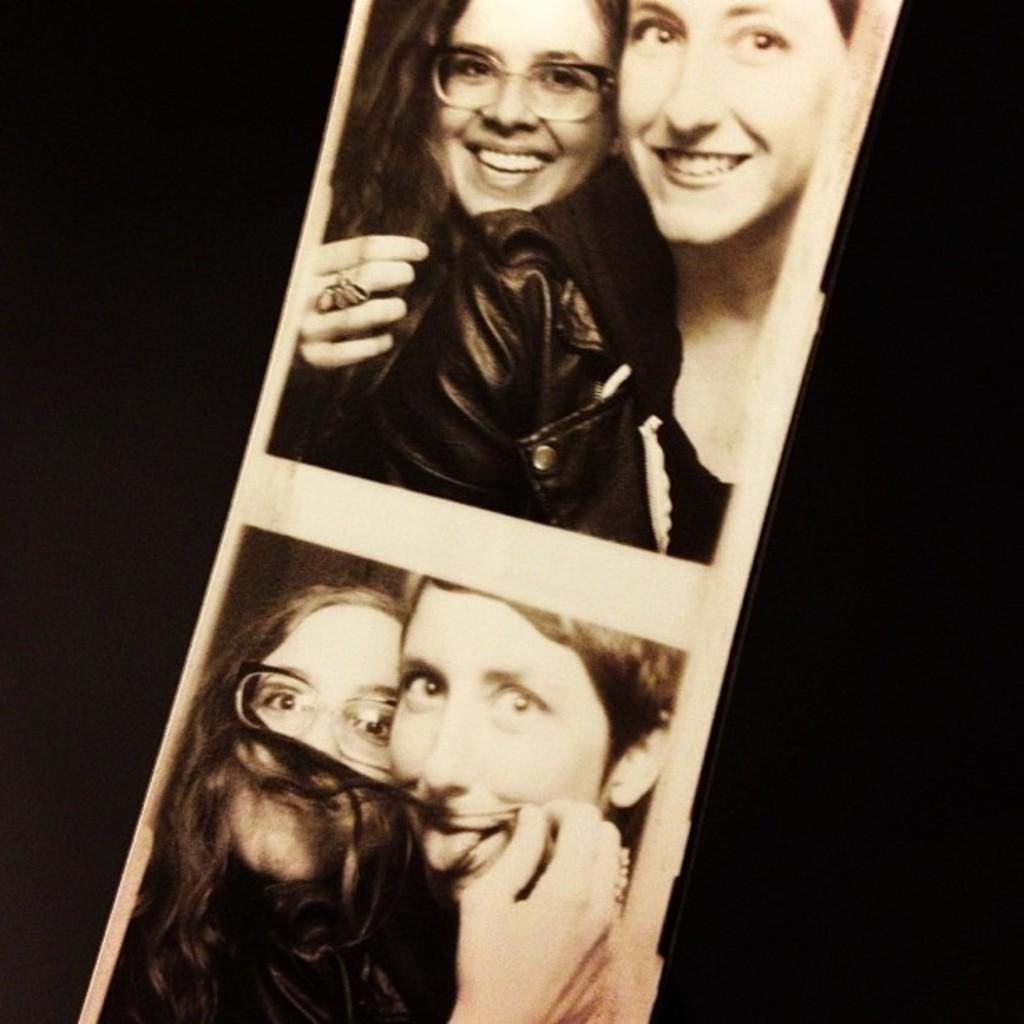What is the nature of the images in the collage? The images are edited and made as a collage. How many people are present in the images? There are two persons in the images. What is the facial expression of the persons? The persons are smiling. What are the persons doing in the images? The persons are giving poses for the picture. What is the color of the background in the images? The background is in black color. What type of animal can be seen in the background of the images? There are no animals visible in the background of the images; the background is in black color. What position is the sheep in the images? There are no sheep present in the images. 